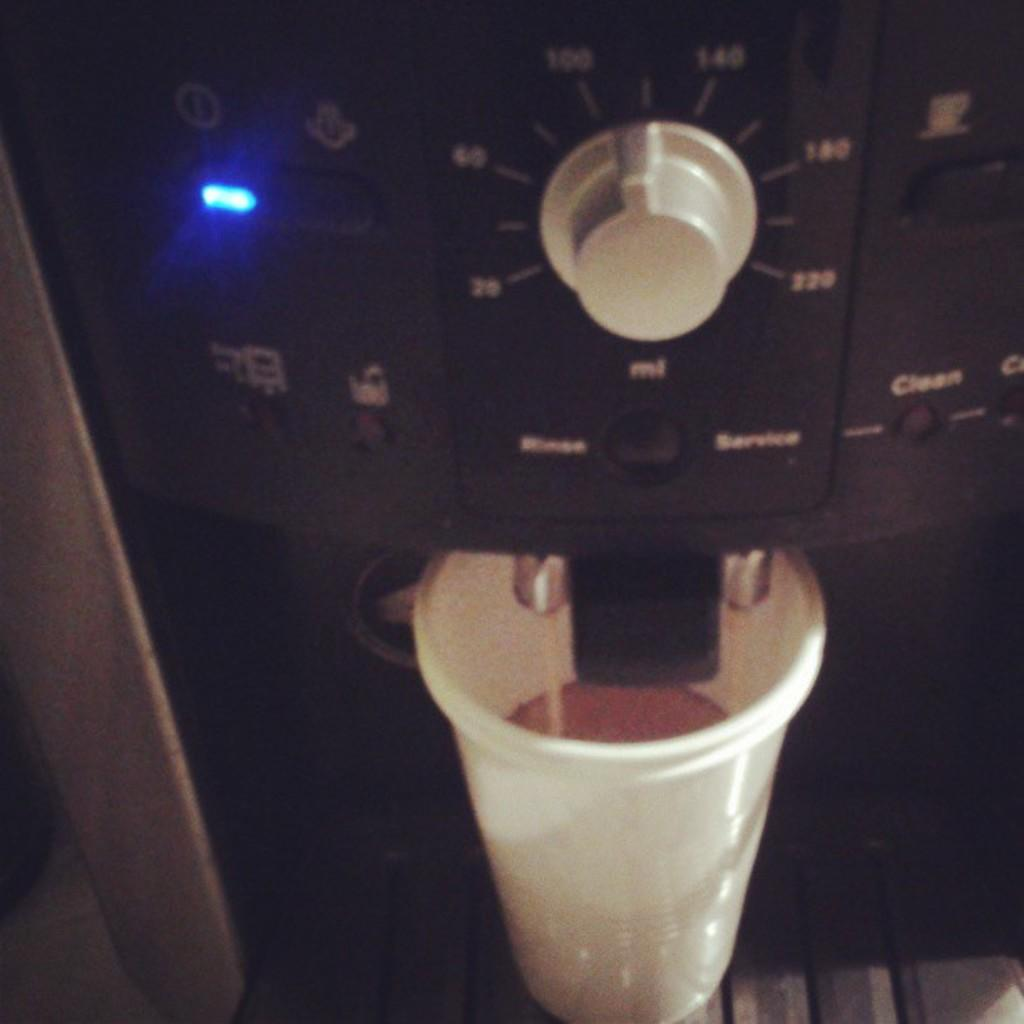What appliance is present in the image? There is a coffee machine in the image. What object is visible alongside the coffee machine? There is a glass in the image. What color is the glass? The glass is white in color. How many dinosaurs can be seen through the window in the image? There is no window or dinosaurs present in the image. 